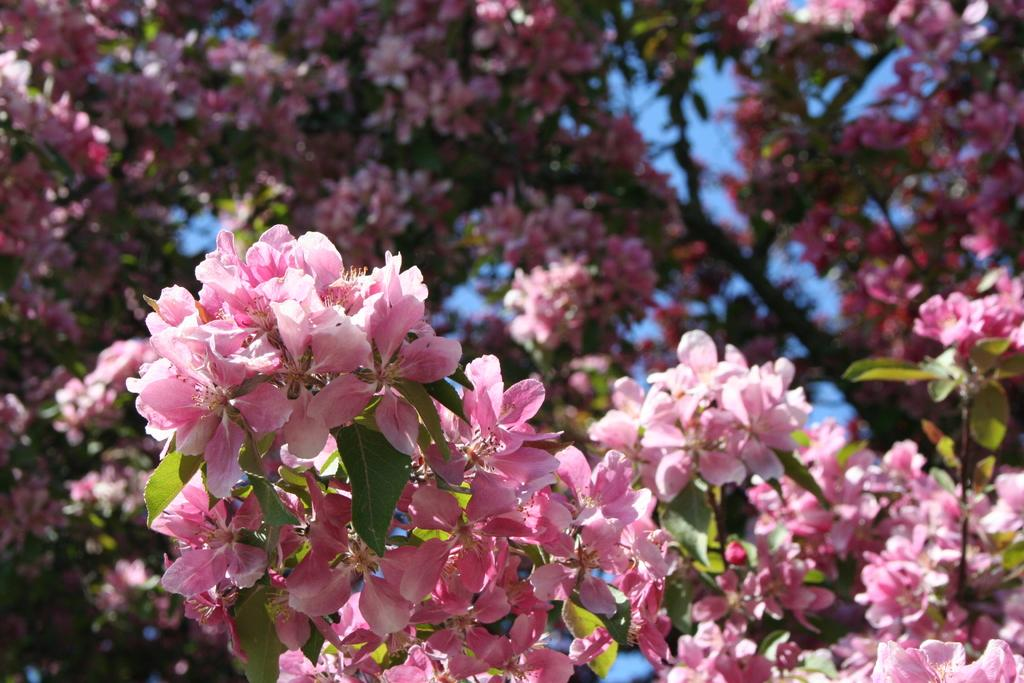What is the main subject of the image? There is a tree in the image. What specific features can be observed on the tree? The tree has flowers and leaves. What color are the flowers on the tree? The flowers on the tree are pink. What can be seen in the background of the image? The sky is visible in the background of the image. How many fingers are visible in the image? There are no fingers visible in the image; it features a tree with flowers and leaves. What type of pies are being served in the image? There are no pies present in the image; it features a tree with flowers and leaves. 